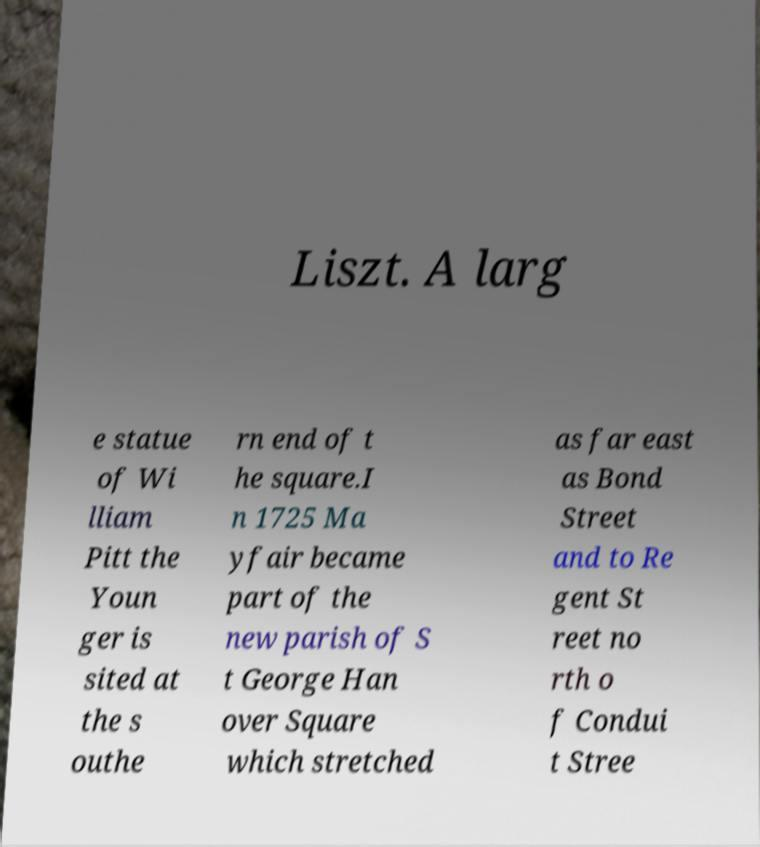Please identify and transcribe the text found in this image. Liszt. A larg e statue of Wi lliam Pitt the Youn ger is sited at the s outhe rn end of t he square.I n 1725 Ma yfair became part of the new parish of S t George Han over Square which stretched as far east as Bond Street and to Re gent St reet no rth o f Condui t Stree 